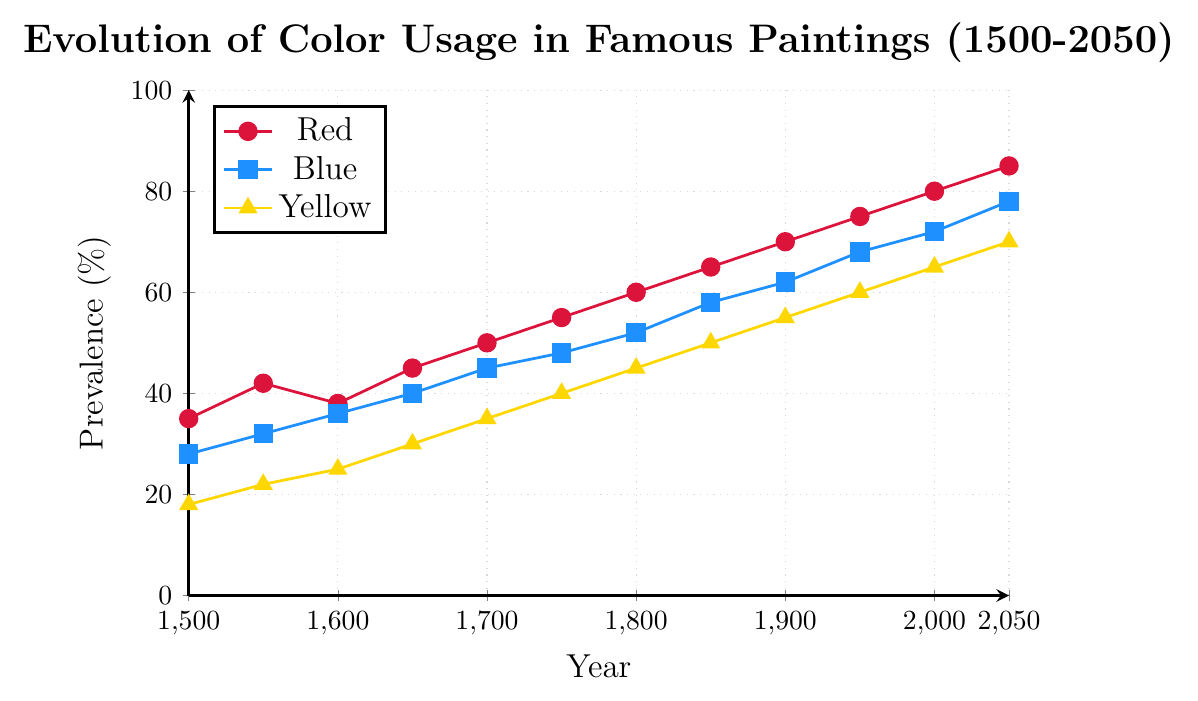How has the usage of red in paintings changed from 1500 to 2050? The usage of red in paintings has increased steadily from 35% in 1500 to 85% in 2050.
Answer: It has increased Which color had the least prevalence in the year 1700? In 1700, the usage percentages for the colors were: Red - 50%, Blue - 45%, Yellow - 35%. Yellow had the least prevalence.
Answer: Yellow Between which years did the usage of blue increase the most? The usage of blue increased the most between 2000 and 2050, from 72% to 78%, an increase of 6%.
Answer: Between 2000 and 2050 What is the average prevalence of the primary colors in the year 2000? In 2000, the prevalences were: Red - 80%, Blue - 72%, Yellow - 65%. The average is (80 + 72 + 65) / 3 = 72.33%.
Answer: 72.33% By how much did the usage of yellow increase from 1750 to 1850? In 1750, Yellow was at 40%, and in 1850, it reached 50%. The increase is 50 - 40 = 10%.
Answer: 10% Which color had the highest prevalence in the year 1950? In 1950, the percentages were: Red - 75%, Blue - 68%, Yellow - 60%. Red had the highest prevalence.
Answer: Red Compare the increase in red and blue from 1500 to 2000? From 1500 to 2000, Red increased from 35% to 80%, which is an increase of 45%. Blue increased from 28% to 72%, which is an increase of 44%. Thus, the increase in red was 1% more than blue.
Answer: Red increased more by 1% Did the usage of any color ever decrease over any 50-year period? Examining the data, all colors show a consistent increase over every 50-year period from 1500 to 2050. None of the colors ever decreased.
Answer: No In which year were the prevalences of blue and yellow closest to each other? The prevalence percentages are closest in 1900, where Blue was at 62% and Yellow was at 55%, with a difference of 7%.
Answer: 1900 